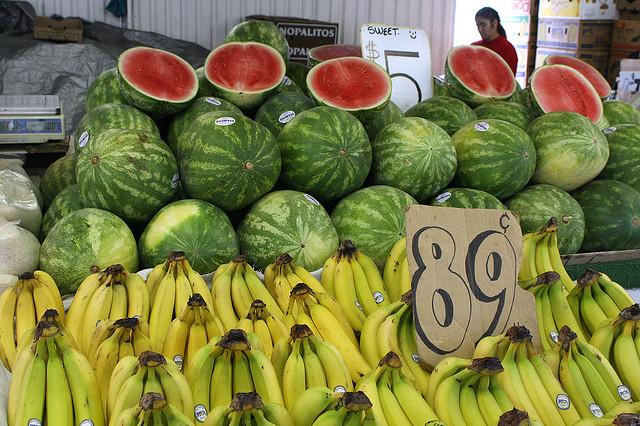Is this a market?
Concise answer only. Yes. How much do the bananas cost?
Quick response, please. 89 cents. Are all of the melons whole?
Short answer required. No. 